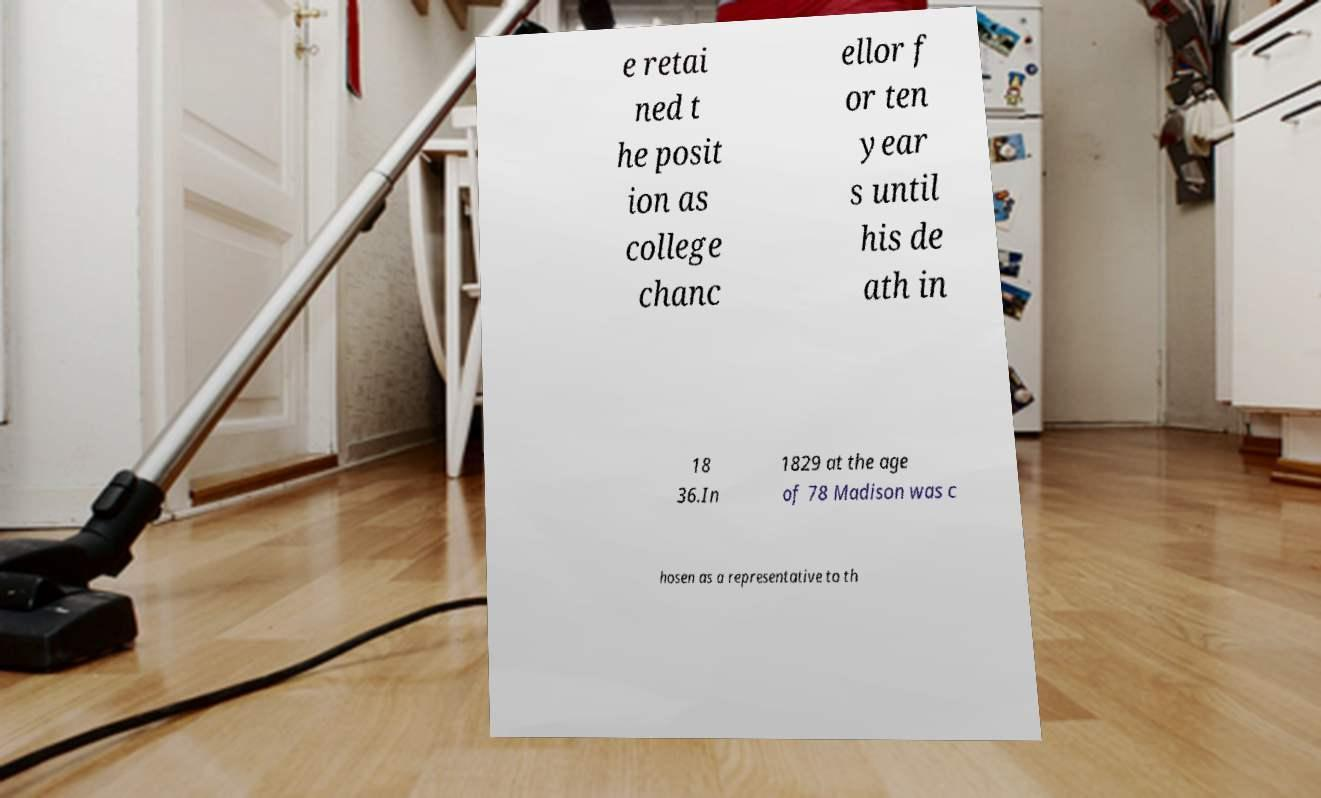Please read and relay the text visible in this image. What does it say? e retai ned t he posit ion as college chanc ellor f or ten year s until his de ath in 18 36.In 1829 at the age of 78 Madison was c hosen as a representative to th 